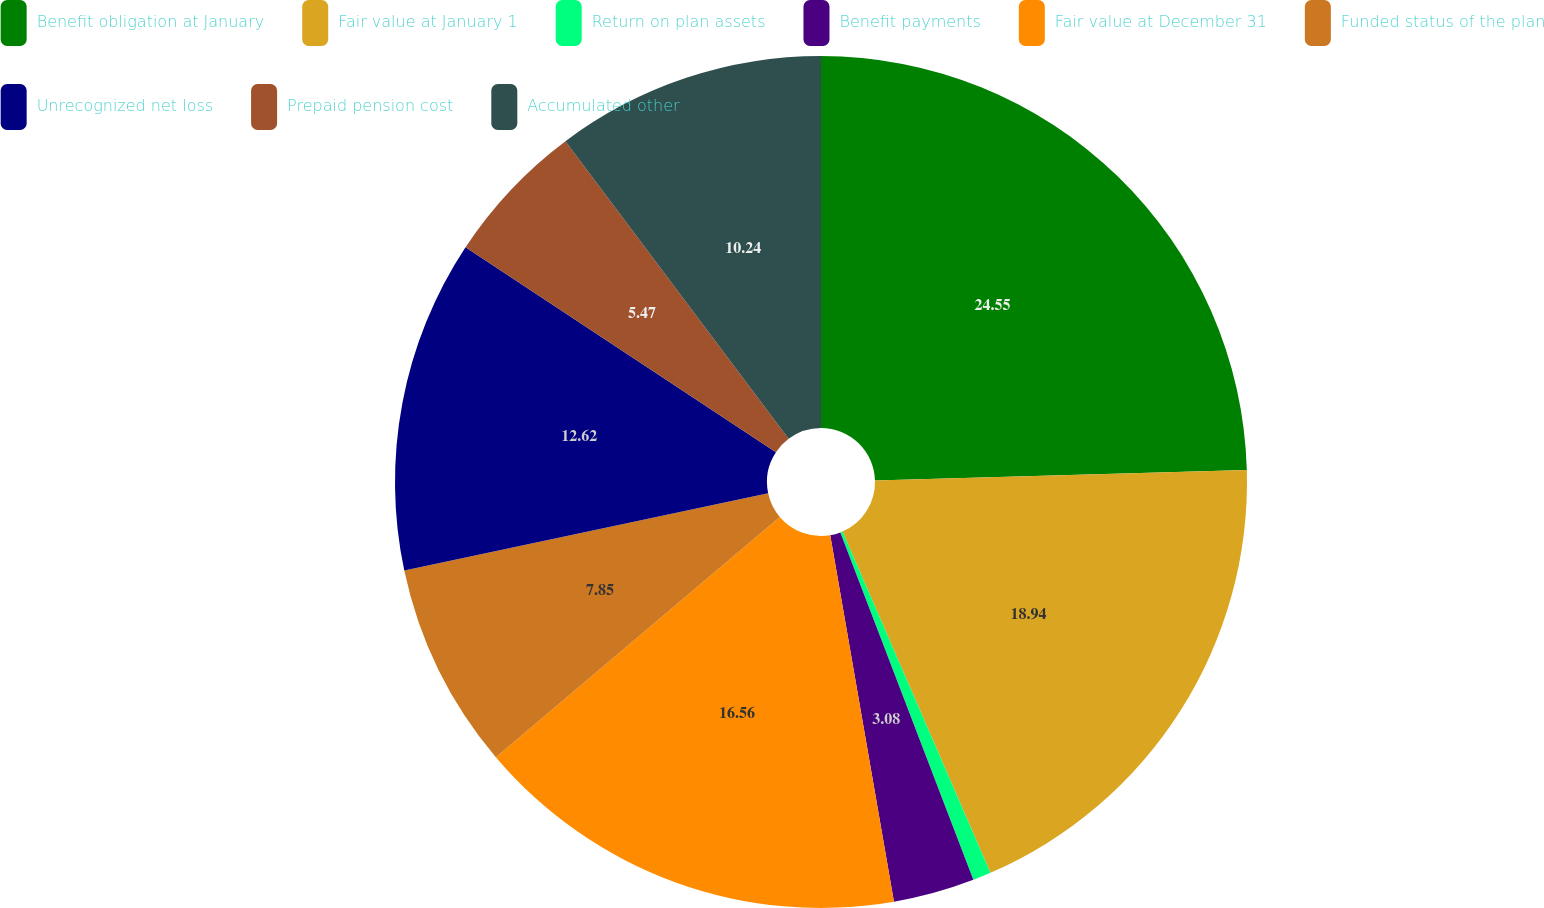<chart> <loc_0><loc_0><loc_500><loc_500><pie_chart><fcel>Benefit obligation at January<fcel>Fair value at January 1<fcel>Return on plan assets<fcel>Benefit payments<fcel>Fair value at December 31<fcel>Funded status of the plan<fcel>Unrecognized net loss<fcel>Prepaid pension cost<fcel>Accumulated other<nl><fcel>24.55%<fcel>18.94%<fcel>0.69%<fcel>3.08%<fcel>16.56%<fcel>7.85%<fcel>12.62%<fcel>5.47%<fcel>10.24%<nl></chart> 